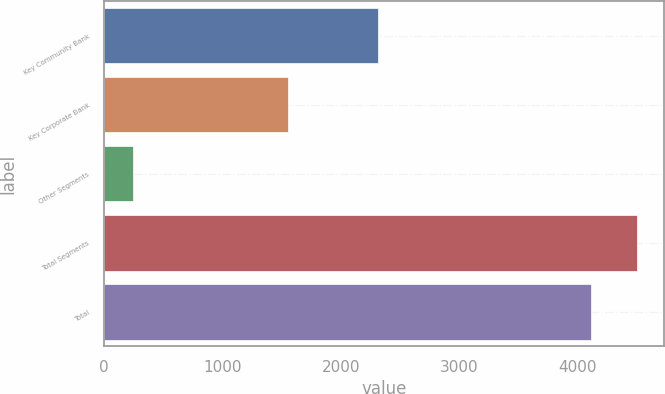Convert chart to OTSL. <chart><loc_0><loc_0><loc_500><loc_500><bar_chart><fcel>Key Community Bank<fcel>Key Corporate Bank<fcel>Other Segments<fcel>Total Segments<fcel>Total<nl><fcel>2315<fcel>1557<fcel>243<fcel>4501.2<fcel>4114<nl></chart> 